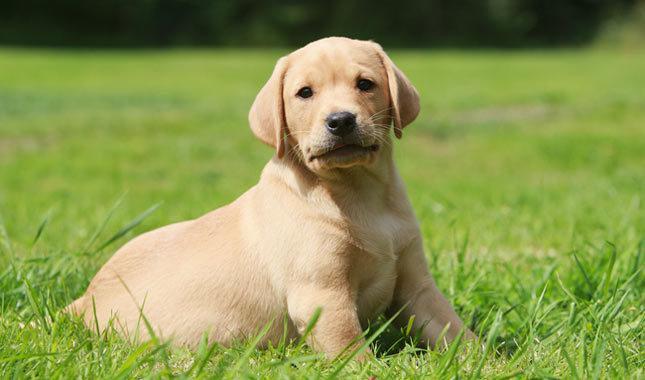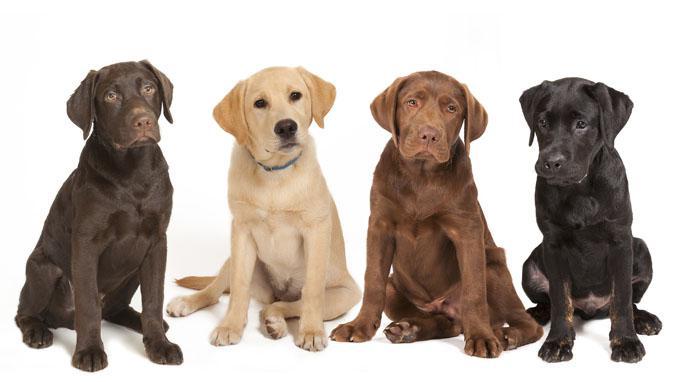The first image is the image on the left, the second image is the image on the right. Analyze the images presented: Is the assertion "There are no less than four dogs" valid? Answer yes or no. Yes. 